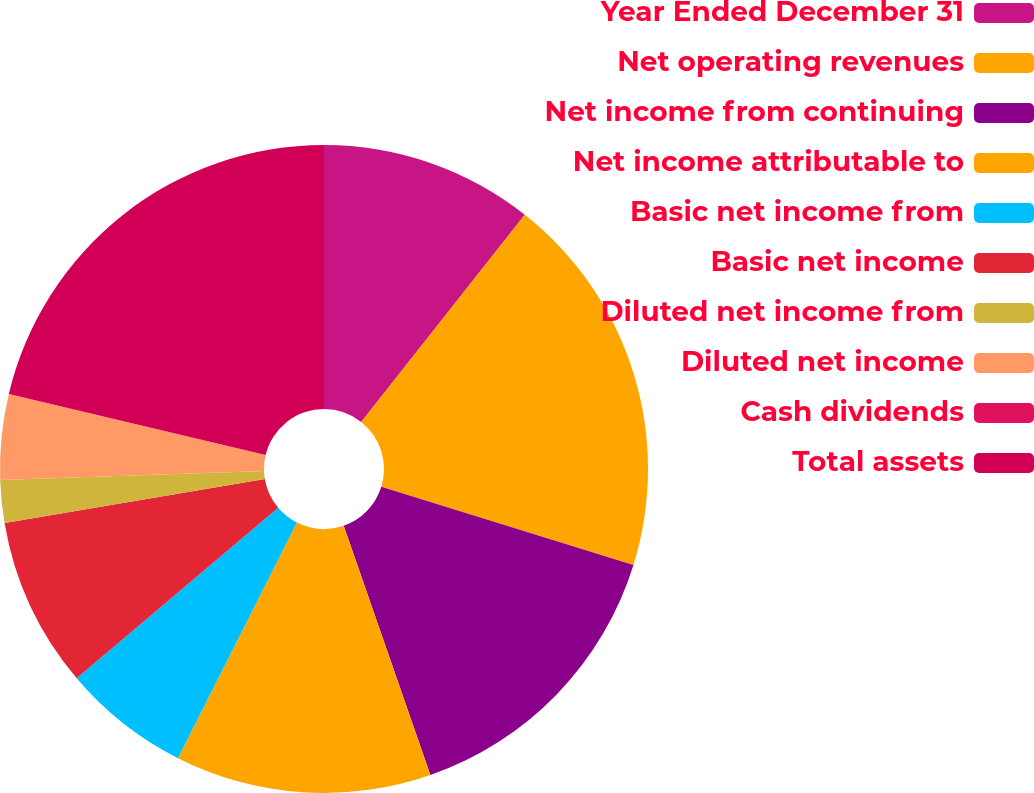Convert chart. <chart><loc_0><loc_0><loc_500><loc_500><pie_chart><fcel>Year Ended December 31<fcel>Net operating revenues<fcel>Net income from continuing<fcel>Net income attributable to<fcel>Basic net income from<fcel>Basic net income<fcel>Diluted net income from<fcel>Diluted net income<fcel>Cash dividends<fcel>Total assets<nl><fcel>10.64%<fcel>19.15%<fcel>14.89%<fcel>12.77%<fcel>6.38%<fcel>8.51%<fcel>2.13%<fcel>4.26%<fcel>0.0%<fcel>21.28%<nl></chart> 